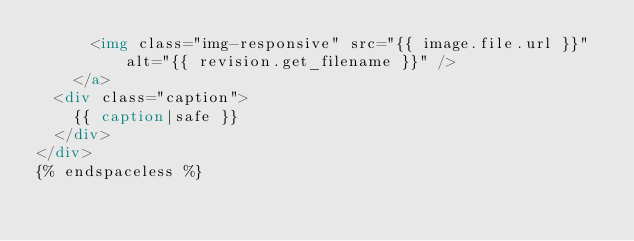<code> <loc_0><loc_0><loc_500><loc_500><_HTML_>      <img class="img-responsive" src="{{ image.file.url }}" alt="{{ revision.get_filename }}" />
    </a>
  <div class="caption">
    {{ caption|safe }}
  </div>
</div>
{% endspaceless %}
</code> 